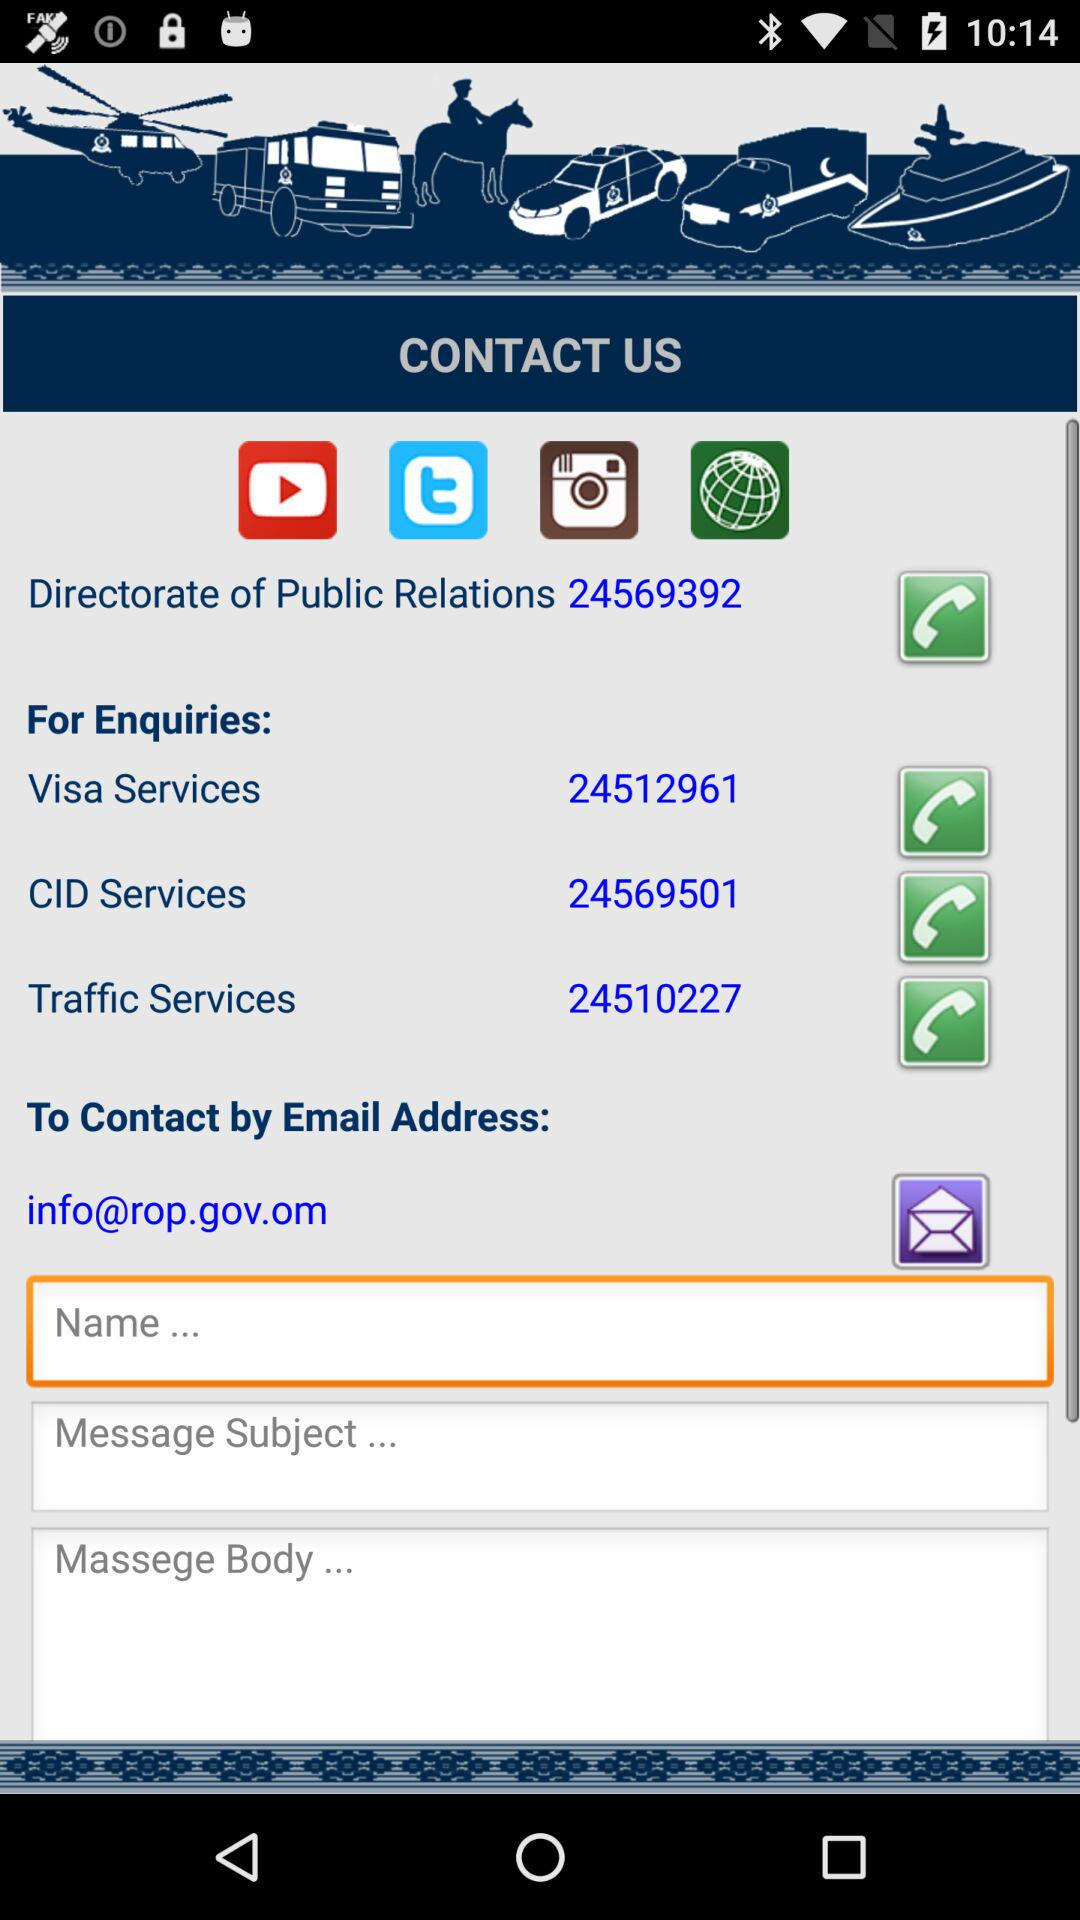What's the phone number for Visa services? The phone number for Visa services is 24512961. 